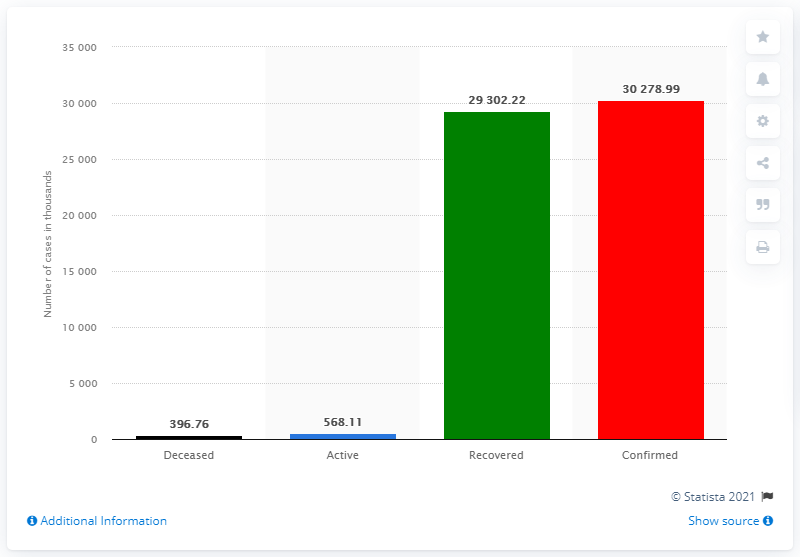Give some essential details in this illustration. The difference between the confirmed and recovered numbers is 976.77... There were 568.11 reported cases of active coronavirus infections as of [date]. 